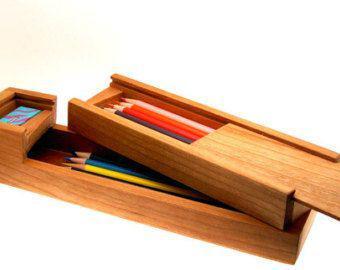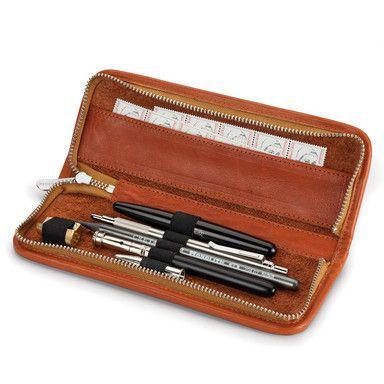The first image is the image on the left, the second image is the image on the right. For the images displayed, is the sentence "An image features a wooden pencil box that slides open, revealing several colored-lead pencils insides." factually correct? Answer yes or no. Yes. The first image is the image on the left, the second image is the image on the right. For the images shown, is this caption "The sliding top of a wooden pencil box is opened to display two levels of storage with an end space to store a sharpener, while a leather pencil case is shown in a second image." true? Answer yes or no. Yes. 